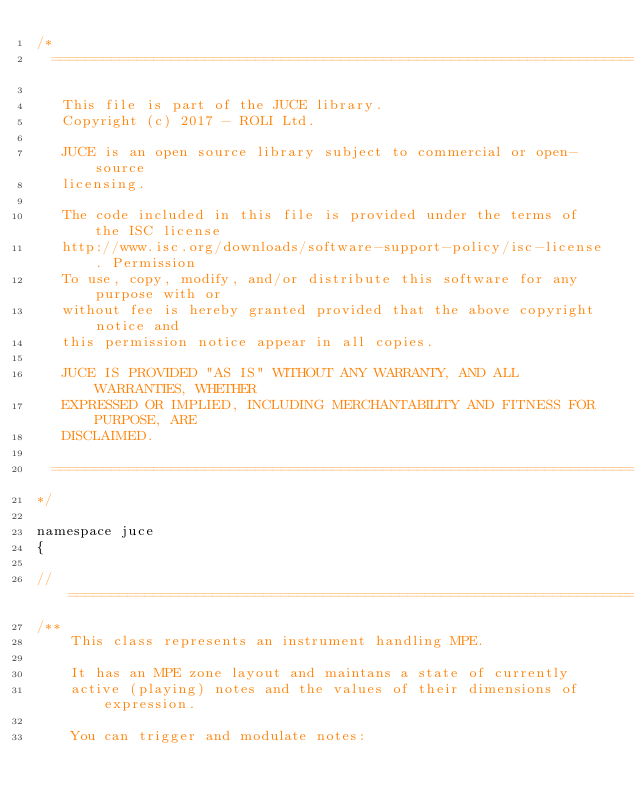Convert code to text. <code><loc_0><loc_0><loc_500><loc_500><_C_>/*
  ==============================================================================

   This file is part of the JUCE library.
   Copyright (c) 2017 - ROLI Ltd.

   JUCE is an open source library subject to commercial or open-source
   licensing.

   The code included in this file is provided under the terms of the ISC license
   http://www.isc.org/downloads/software-support-policy/isc-license. Permission
   To use, copy, modify, and/or distribute this software for any purpose with or
   without fee is hereby granted provided that the above copyright notice and
   this permission notice appear in all copies.

   JUCE IS PROVIDED "AS IS" WITHOUT ANY WARRANTY, AND ALL WARRANTIES, WHETHER
   EXPRESSED OR IMPLIED, INCLUDING MERCHANTABILITY AND FITNESS FOR PURPOSE, ARE
   DISCLAIMED.

  ==============================================================================
*/

namespace juce
{

//==============================================================================
/**
    This class represents an instrument handling MPE.

    It has an MPE zone layout and maintans a state of currently
    active (playing) notes and the values of their dimensions of expression.

    You can trigger and modulate notes:</code> 